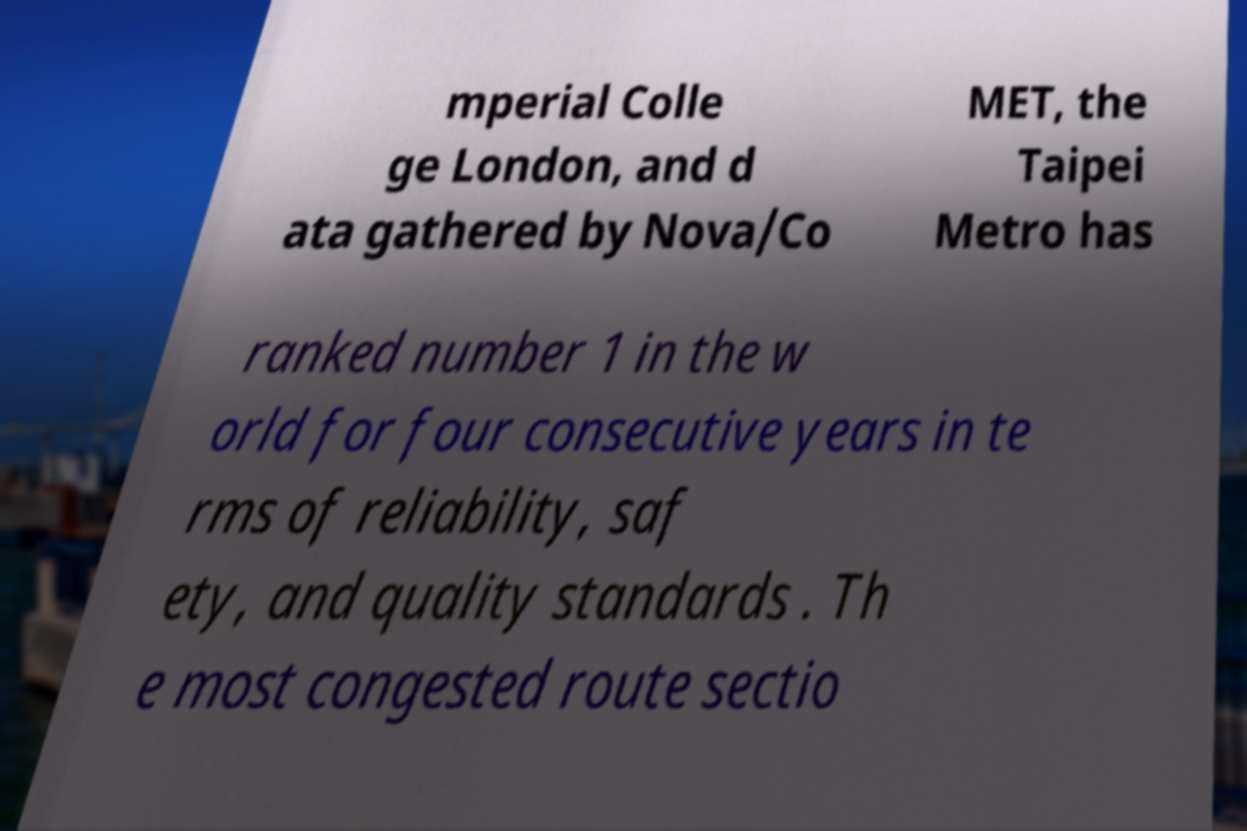There's text embedded in this image that I need extracted. Can you transcribe it verbatim? mperial Colle ge London, and d ata gathered by Nova/Co MET, the Taipei Metro has ranked number 1 in the w orld for four consecutive years in te rms of reliability, saf ety, and quality standards . Th e most congested route sectio 